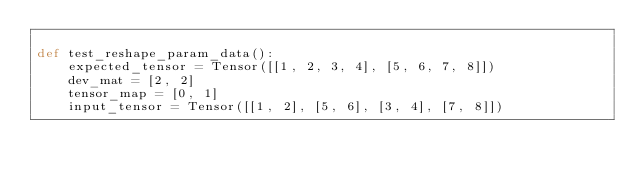<code> <loc_0><loc_0><loc_500><loc_500><_Python_>
def test_reshape_param_data():
    expected_tensor = Tensor([[1, 2, 3, 4], [5, 6, 7, 8]])
    dev_mat = [2, 2]
    tensor_map = [0, 1]
    input_tensor = Tensor([[1, 2], [5, 6], [3, 4], [7, 8]])</code> 